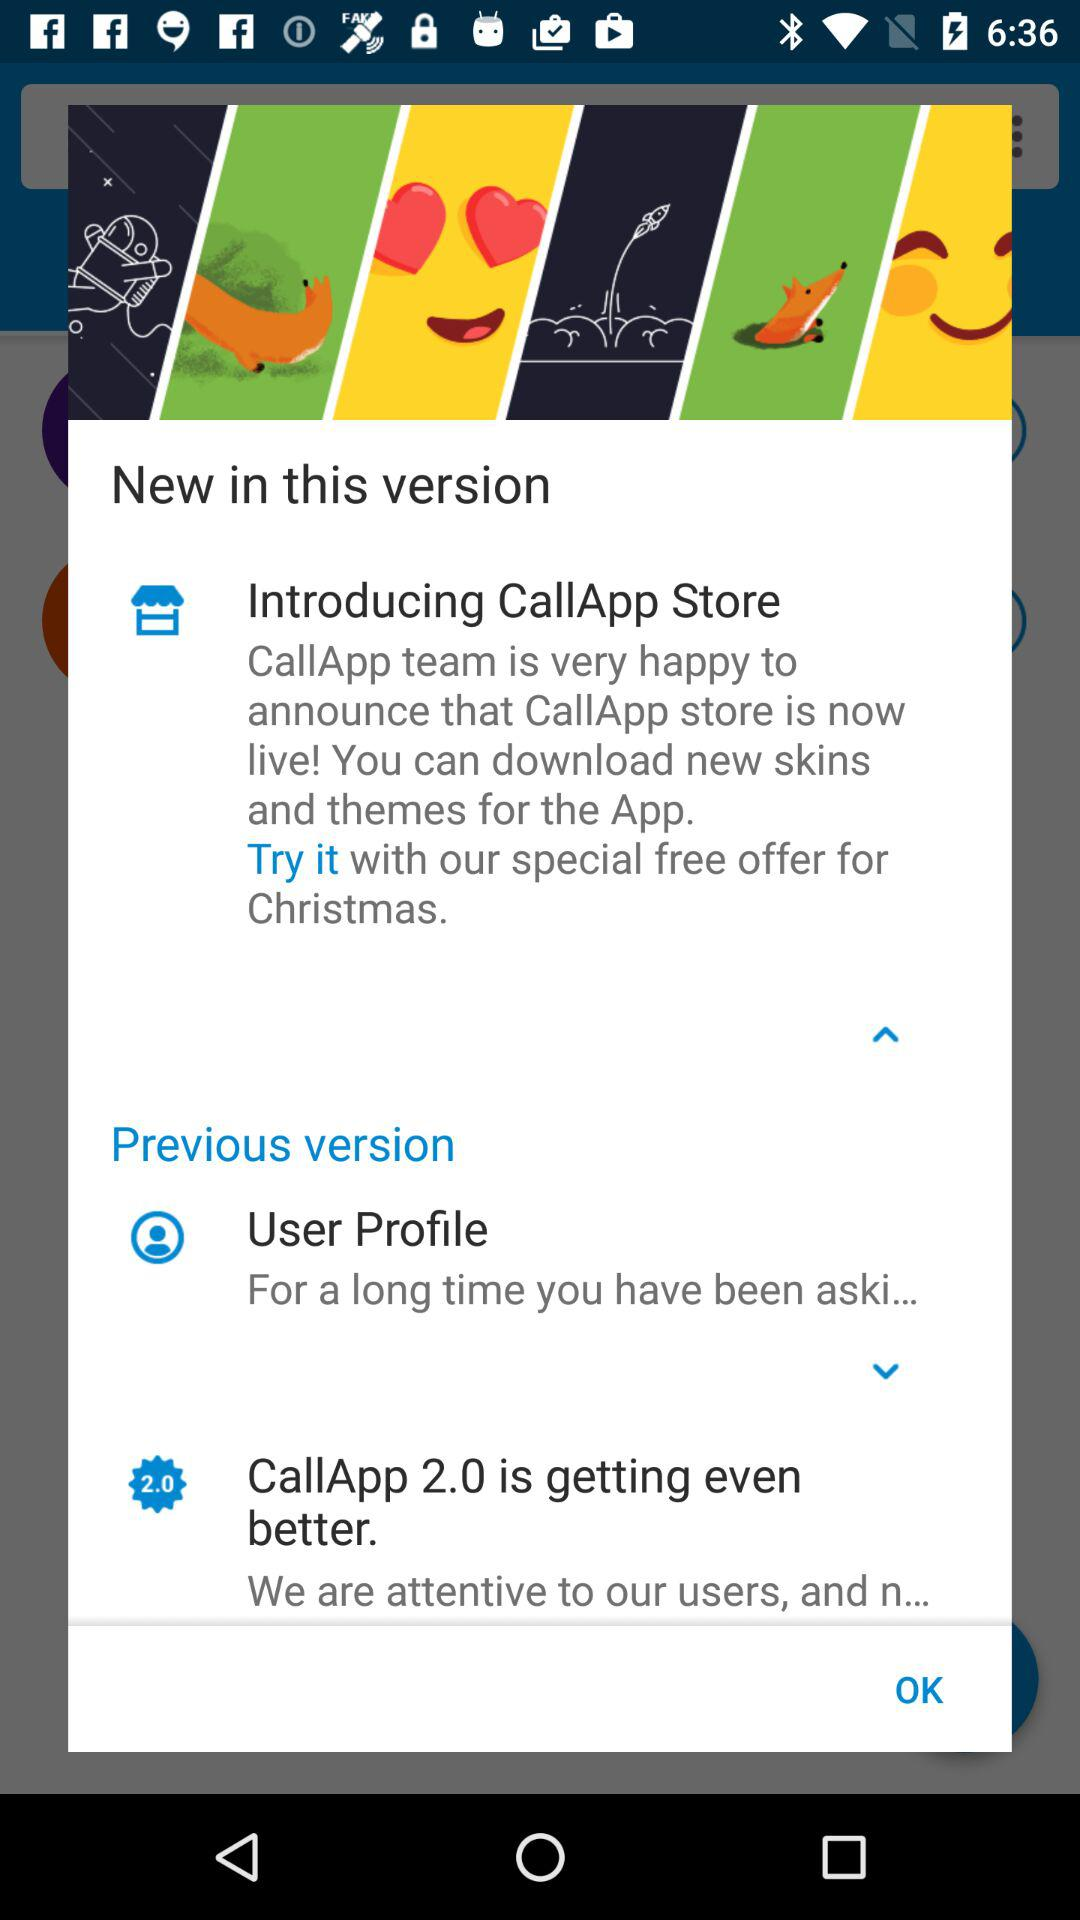Which is the version of the "CallApp" application? The version of the "CallApp" application is 2.0. 